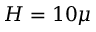Convert formula to latex. <formula><loc_0><loc_0><loc_500><loc_500>H = 1 0 \mu</formula> 